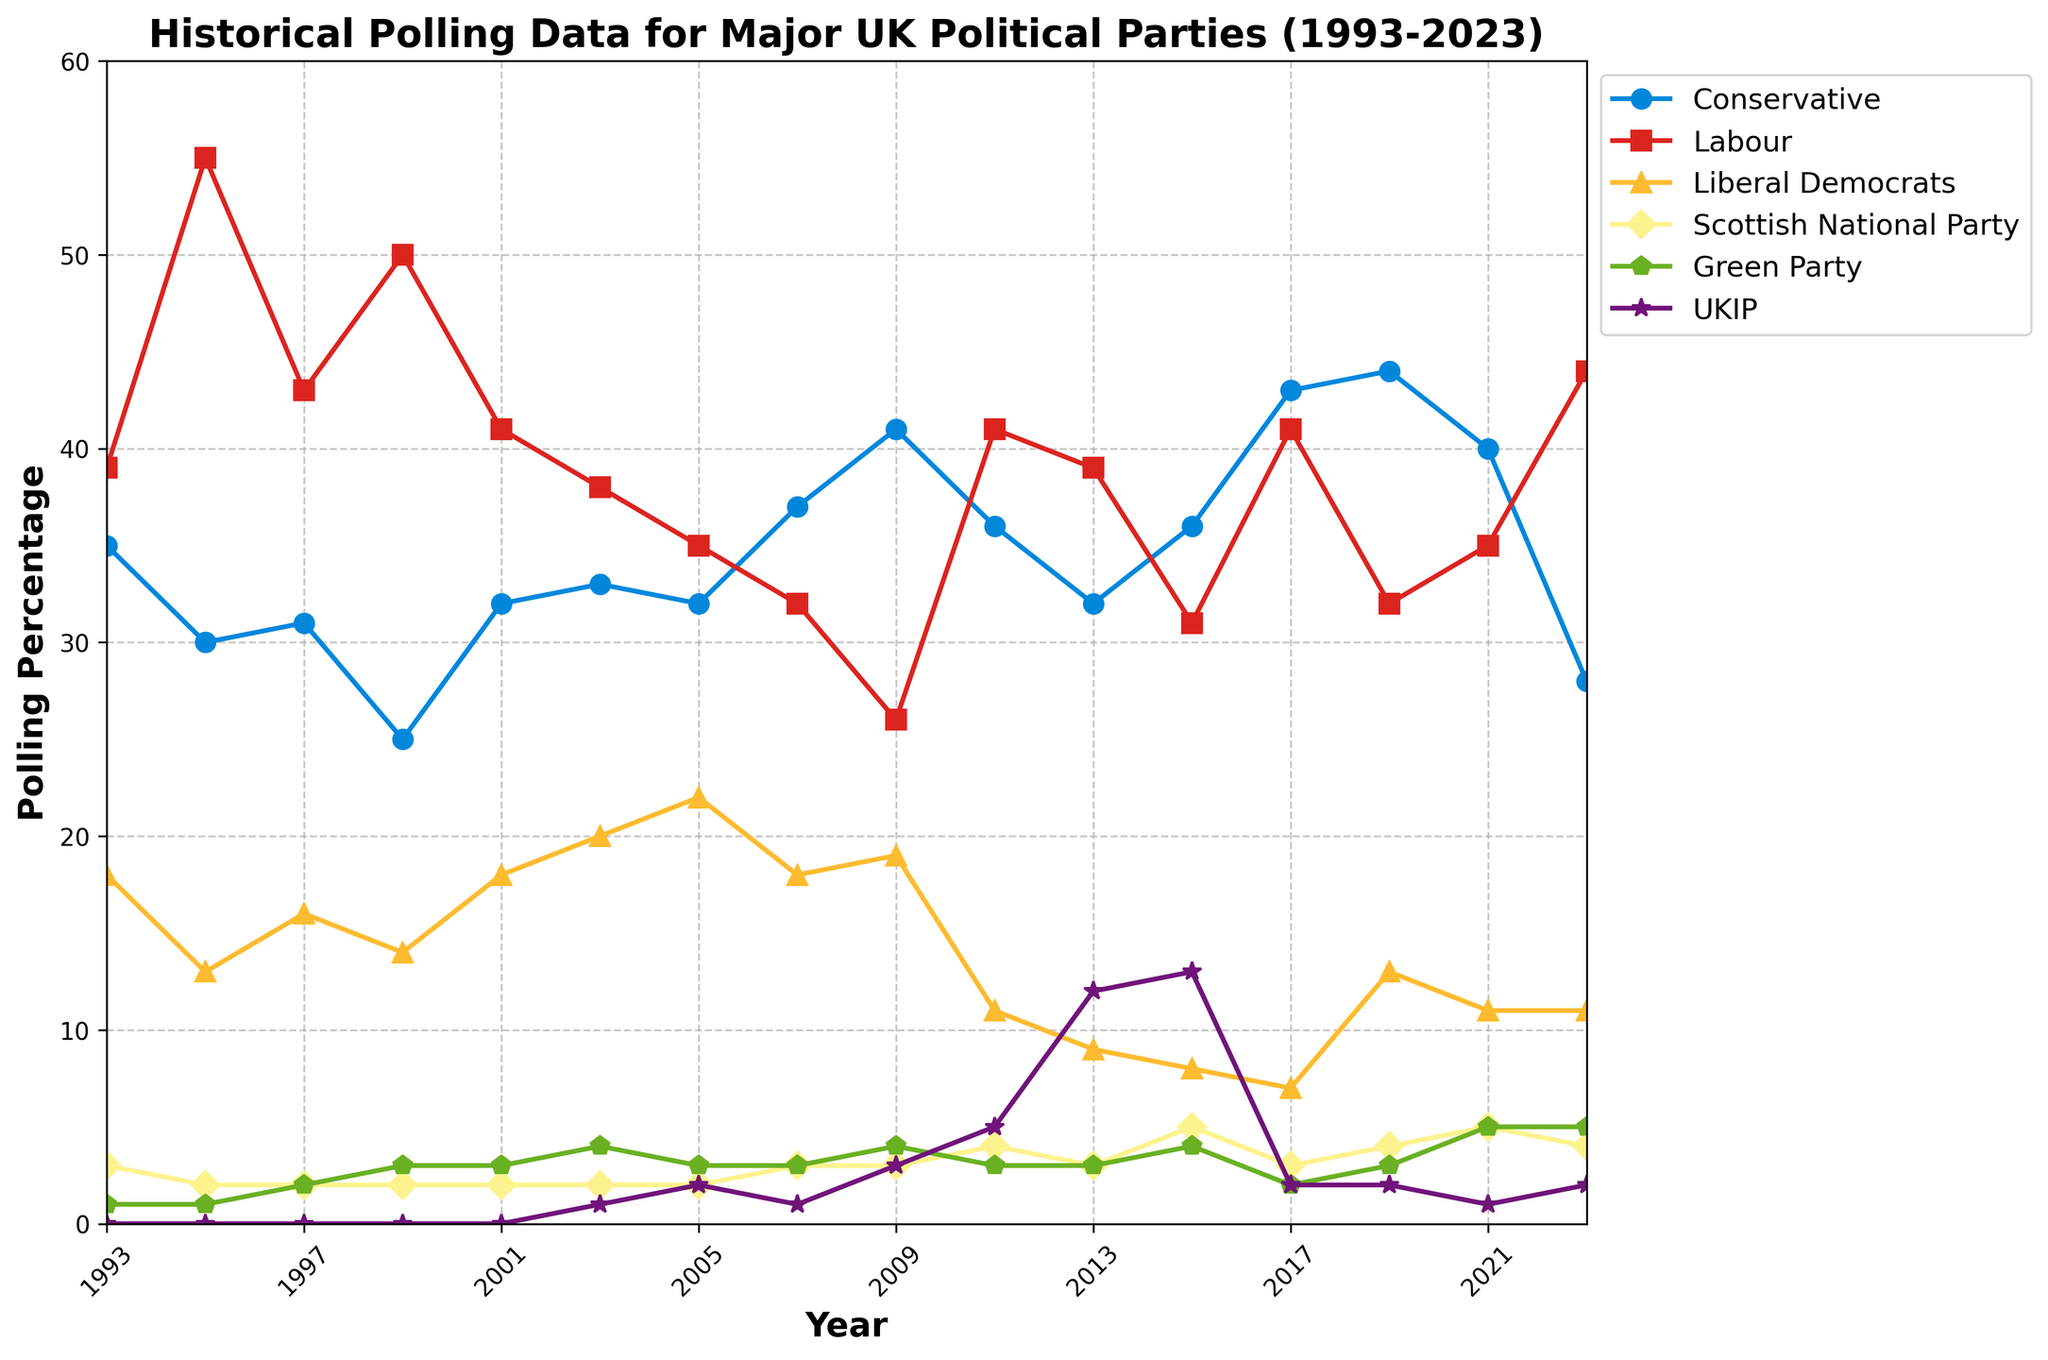What year did the Conservative Party experience its highest polling percentage? Looking at the 'Conservative' line in blue, the peak point can be observed around 2019 where the percentage is at its highest.
Answer: 2019 In which year did Labour have its highest polling percentage and what was it? To find Labour's highest polling percentage, examine the red line. The highest point appears around 1995 with a percentage of 55.
Answer: 1995, 55% How does the polling percentage difference between Conservatives and Labour change from 1993 to 2023? In 1993, Conservatives were at 35% and Labour at 39%, a difference of 4%. In 2023, Conservatives were at 28% and Labour at 44%, a difference of 16%.
Answer: Increased from 4% to 16% Between which years did the Liberal Democrats experience their highest increase in polling percentage? Track the yellow line representing the Liberal Democrats. The largest increase is between 2001 (18%) and 2005 (22%), an increase of 4%.
Answer: 2001 to 2005 What is the average polling percentage of the Green Party from 2011 to 2023? The Green Party (green line) polling percentages are: 2011 (3%), 2013 (3%), 2015 (4%), 2017 (2%), 2019 (3%), 2021 (5%), and 2023 (5%). Sum these values and divide by the number of years: (3+3+4+2+3+5+5)/7 = 25/7 ≈ 3.57%.
Answer: 3.57% In which year did UKIP achieve its highest polling percentage and what was the percentage? Look for the peak of the purple line representing UKIP. The peak occurs in 2015 with a percentage of 13%.
Answer: 2015, 13% Which party had the lowest polling percentage in 2023? Review each line's endpoint in 2023. UKIP had the lowest polling percentage with 2%.
Answer: UKIP In 2017, compare the polling percentages of Labour and the Conservatives. What is the difference between them? Labour (red line) in 2017 is at 41%, and Conservatives (blue line) are at 43%. The difference is 43% - 41% = 2%.
Answer: 2% Over the entire period, how many times did the Conservatives have a higher polling percentage than Labour? Compare the blue line (Conservatives) and the red line (Labour) year by year. The years the Conservatives were higher: 2009, 2007, 2015, 2017, 2019, 2021. That's 6 times in total.
Answer: 6 